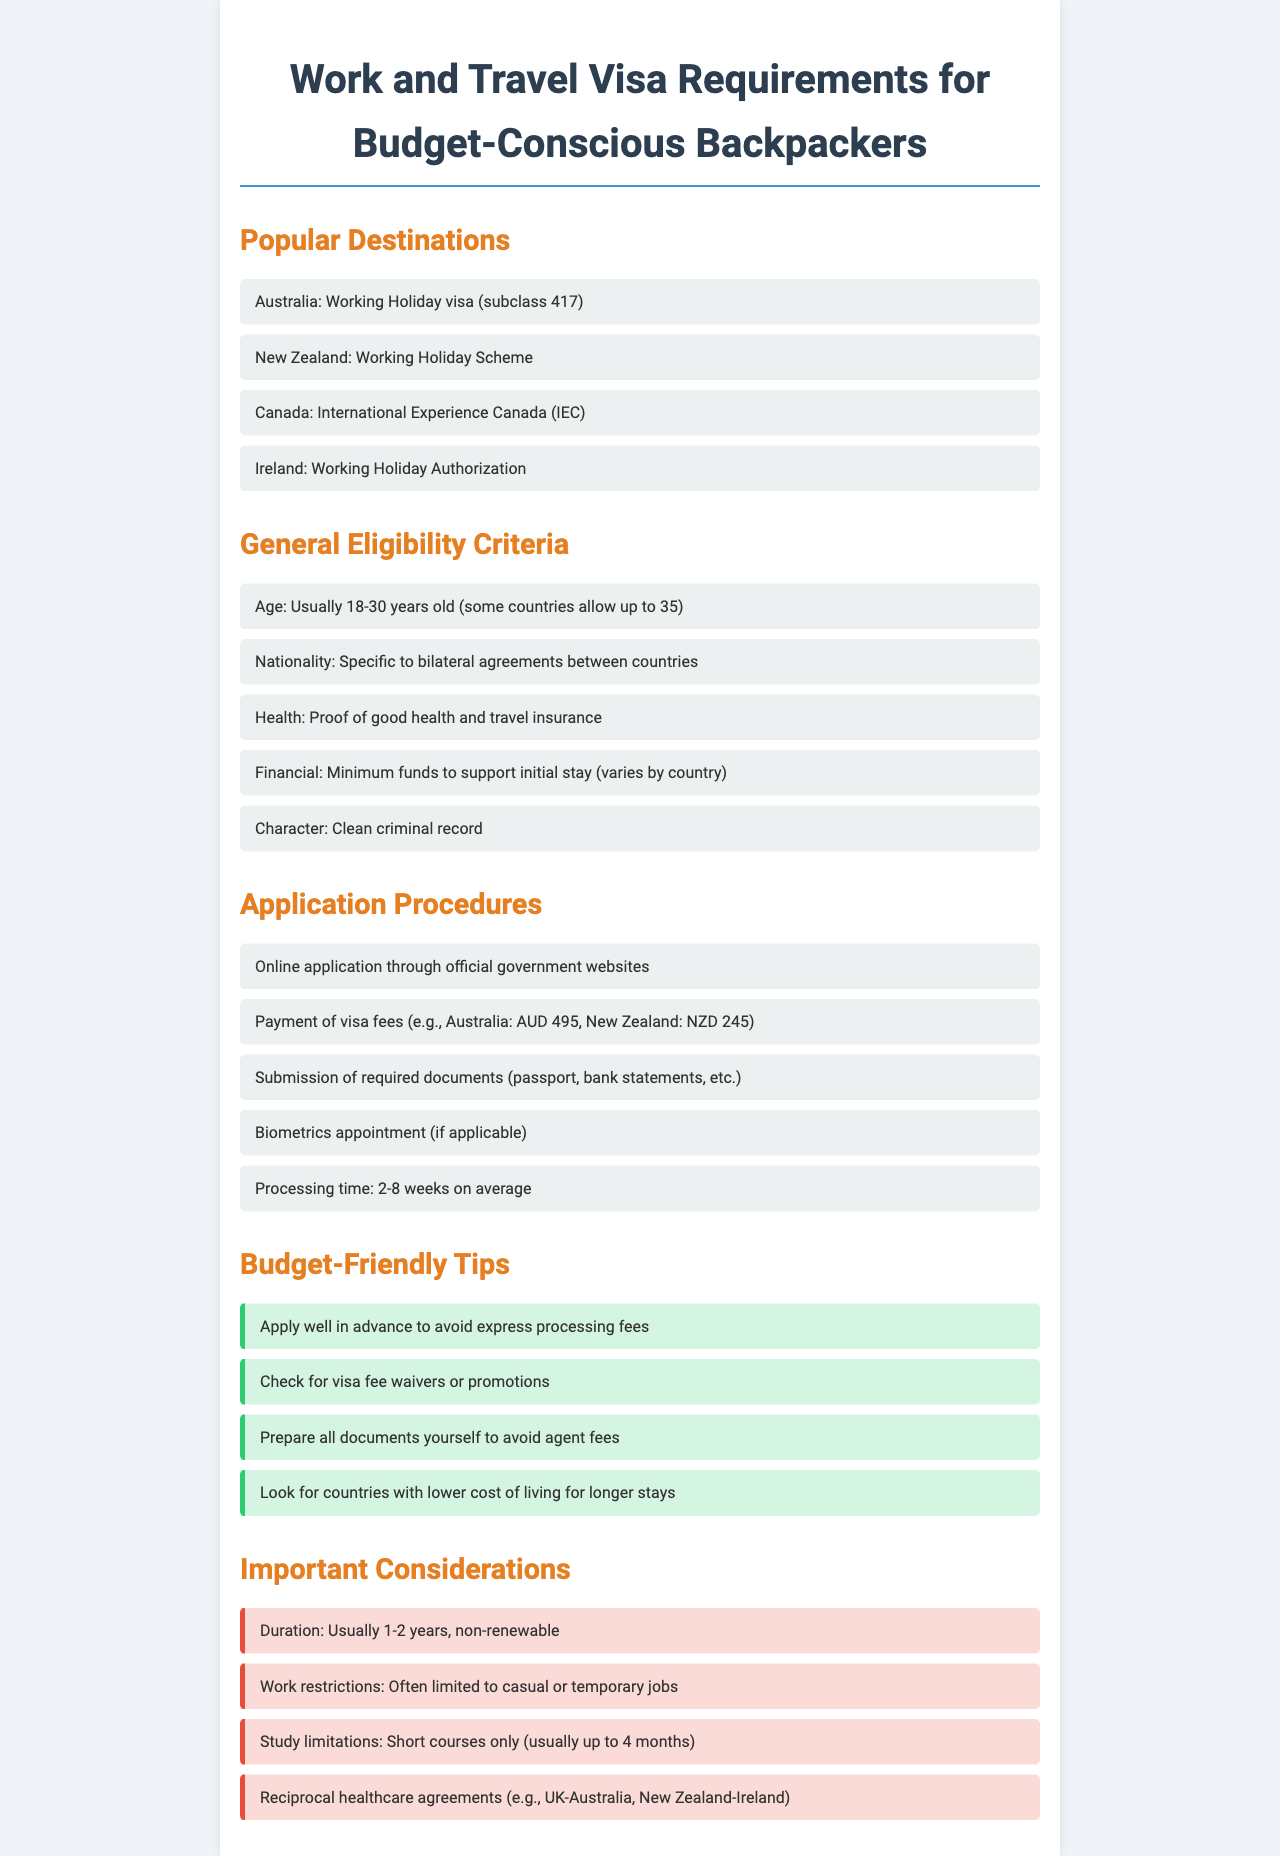What is the visa type for Australia? The document states that the visa type for Australia is the Working Holiday visa (subclass 417).
Answer: Working Holiday visa (subclass 417) What is the maximum age limit for eligibility in most countries? The general eligibility criteria mention that the age is usually up to 30 years old, with some countries allowing up to 35.
Answer: 30 years old What is the application fee for New Zealand's visa? The document lists the payment of visa fees, indicating that New Zealand's fee is NZD 245.
Answer: NZD 245 What is a suggested budget-friendly tip? The budget-friendly tips section recommends applying well in advance to avoid express processing fees.
Answer: Apply well in advance What is a common work restriction mentioned? The document notes that work restrictions often limit applicants to casual or temporary jobs.
Answer: Casual or temporary jobs What documents are typically required for application? The application procedures outline required documents, which include passports and bank statements.
Answer: Passport, bank statements What is the processing time range for visa applications? According to the application procedures, the processing time averages between 2 to 8 weeks.
Answer: 2-8 weeks What usually limits study for visa holders? The important considerations section indicates that study limitations usually apply, restricting courses to short ones.
Answer: Short courses Which country has a reciprocal healthcare agreement mentioned? The important considerations indicate a reciprocal healthcare agreement between the UK and Australia.
Answer: UK-Australia 